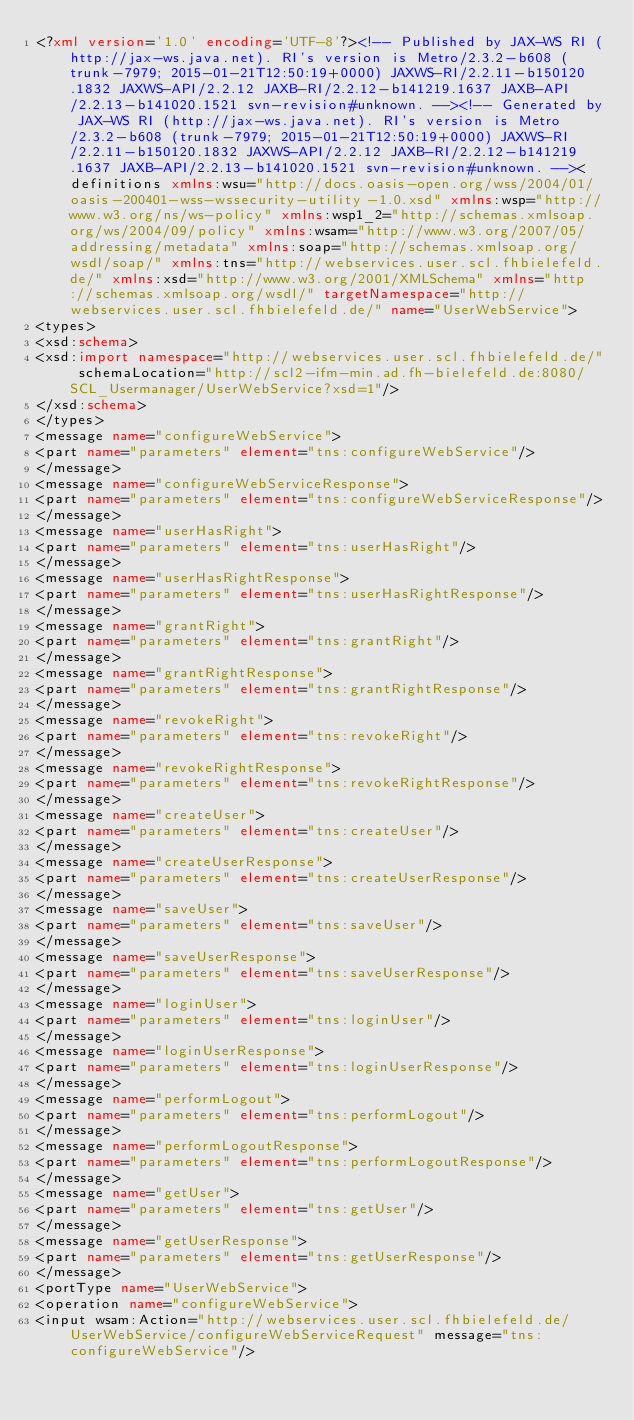Convert code to text. <code><loc_0><loc_0><loc_500><loc_500><_XML_><?xml version='1.0' encoding='UTF-8'?><!-- Published by JAX-WS RI (http://jax-ws.java.net). RI's version is Metro/2.3.2-b608 (trunk-7979; 2015-01-21T12:50:19+0000) JAXWS-RI/2.2.11-b150120.1832 JAXWS-API/2.2.12 JAXB-RI/2.2.12-b141219.1637 JAXB-API/2.2.13-b141020.1521 svn-revision#unknown. --><!-- Generated by JAX-WS RI (http://jax-ws.java.net). RI's version is Metro/2.3.2-b608 (trunk-7979; 2015-01-21T12:50:19+0000) JAXWS-RI/2.2.11-b150120.1832 JAXWS-API/2.2.12 JAXB-RI/2.2.12-b141219.1637 JAXB-API/2.2.13-b141020.1521 svn-revision#unknown. --><definitions xmlns:wsu="http://docs.oasis-open.org/wss/2004/01/oasis-200401-wss-wssecurity-utility-1.0.xsd" xmlns:wsp="http://www.w3.org/ns/ws-policy" xmlns:wsp1_2="http://schemas.xmlsoap.org/ws/2004/09/policy" xmlns:wsam="http://www.w3.org/2007/05/addressing/metadata" xmlns:soap="http://schemas.xmlsoap.org/wsdl/soap/" xmlns:tns="http://webservices.user.scl.fhbielefeld.de/" xmlns:xsd="http://www.w3.org/2001/XMLSchema" xmlns="http://schemas.xmlsoap.org/wsdl/" targetNamespace="http://webservices.user.scl.fhbielefeld.de/" name="UserWebService">
<types>
<xsd:schema>
<xsd:import namespace="http://webservices.user.scl.fhbielefeld.de/" schemaLocation="http://scl2-ifm-min.ad.fh-bielefeld.de:8080/SCL_Usermanager/UserWebService?xsd=1"/>
</xsd:schema>
</types>
<message name="configureWebService">
<part name="parameters" element="tns:configureWebService"/>
</message>
<message name="configureWebServiceResponse">
<part name="parameters" element="tns:configureWebServiceResponse"/>
</message>
<message name="userHasRight">
<part name="parameters" element="tns:userHasRight"/>
</message>
<message name="userHasRightResponse">
<part name="parameters" element="tns:userHasRightResponse"/>
</message>
<message name="grantRight">
<part name="parameters" element="tns:grantRight"/>
</message>
<message name="grantRightResponse">
<part name="parameters" element="tns:grantRightResponse"/>
</message>
<message name="revokeRight">
<part name="parameters" element="tns:revokeRight"/>
</message>
<message name="revokeRightResponse">
<part name="parameters" element="tns:revokeRightResponse"/>
</message>
<message name="createUser">
<part name="parameters" element="tns:createUser"/>
</message>
<message name="createUserResponse">
<part name="parameters" element="tns:createUserResponse"/>
</message>
<message name="saveUser">
<part name="parameters" element="tns:saveUser"/>
</message>
<message name="saveUserResponse">
<part name="parameters" element="tns:saveUserResponse"/>
</message>
<message name="loginUser">
<part name="parameters" element="tns:loginUser"/>
</message>
<message name="loginUserResponse">
<part name="parameters" element="tns:loginUserResponse"/>
</message>
<message name="performLogout">
<part name="parameters" element="tns:performLogout"/>
</message>
<message name="performLogoutResponse">
<part name="parameters" element="tns:performLogoutResponse"/>
</message>
<message name="getUser">
<part name="parameters" element="tns:getUser"/>
</message>
<message name="getUserResponse">
<part name="parameters" element="tns:getUserResponse"/>
</message>
<portType name="UserWebService">
<operation name="configureWebService">
<input wsam:Action="http://webservices.user.scl.fhbielefeld.de/UserWebService/configureWebServiceRequest" message="tns:configureWebService"/></code> 